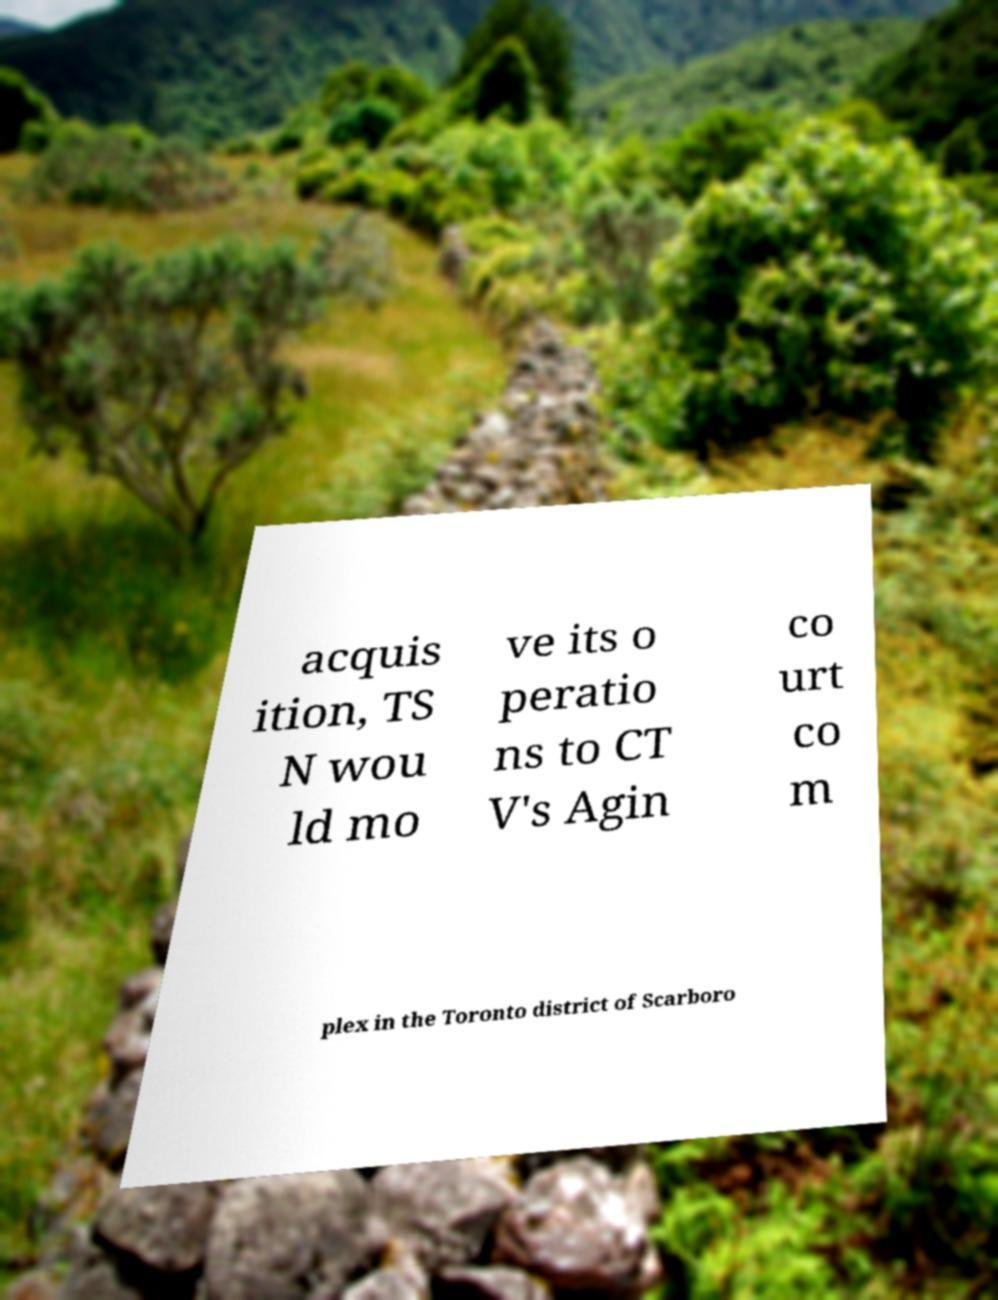Can you accurately transcribe the text from the provided image for me? acquis ition, TS N wou ld mo ve its o peratio ns to CT V's Agin co urt co m plex in the Toronto district of Scarboro 